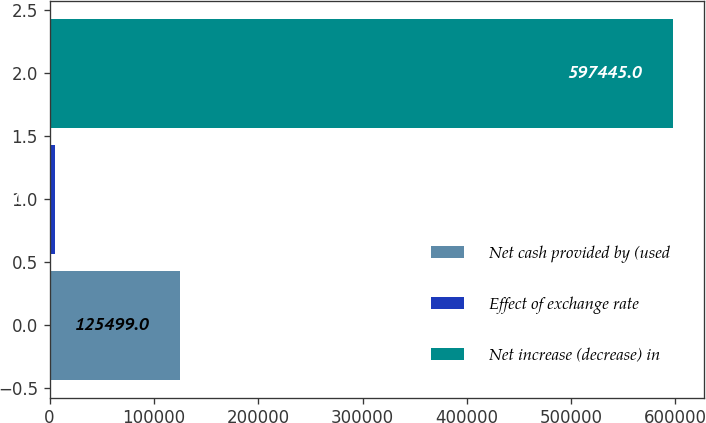Convert chart. <chart><loc_0><loc_0><loc_500><loc_500><bar_chart><fcel>Net cash provided by (used<fcel>Effect of exchange rate<fcel>Net increase (decrease) in<nl><fcel>125499<fcel>5535<fcel>597445<nl></chart> 